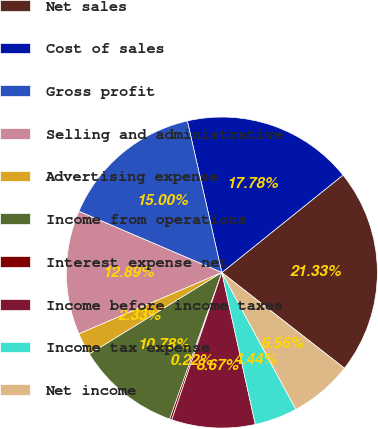Convert chart. <chart><loc_0><loc_0><loc_500><loc_500><pie_chart><fcel>Net sales<fcel>Cost of sales<fcel>Gross profit<fcel>Selling and administrative<fcel>Advertising expense<fcel>Income from operations<fcel>Interest expense net<fcel>Income before income taxes<fcel>Income tax expense<fcel>Net income<nl><fcel>21.33%<fcel>17.78%<fcel>15.0%<fcel>12.89%<fcel>2.33%<fcel>10.78%<fcel>0.22%<fcel>8.67%<fcel>4.44%<fcel>6.56%<nl></chart> 